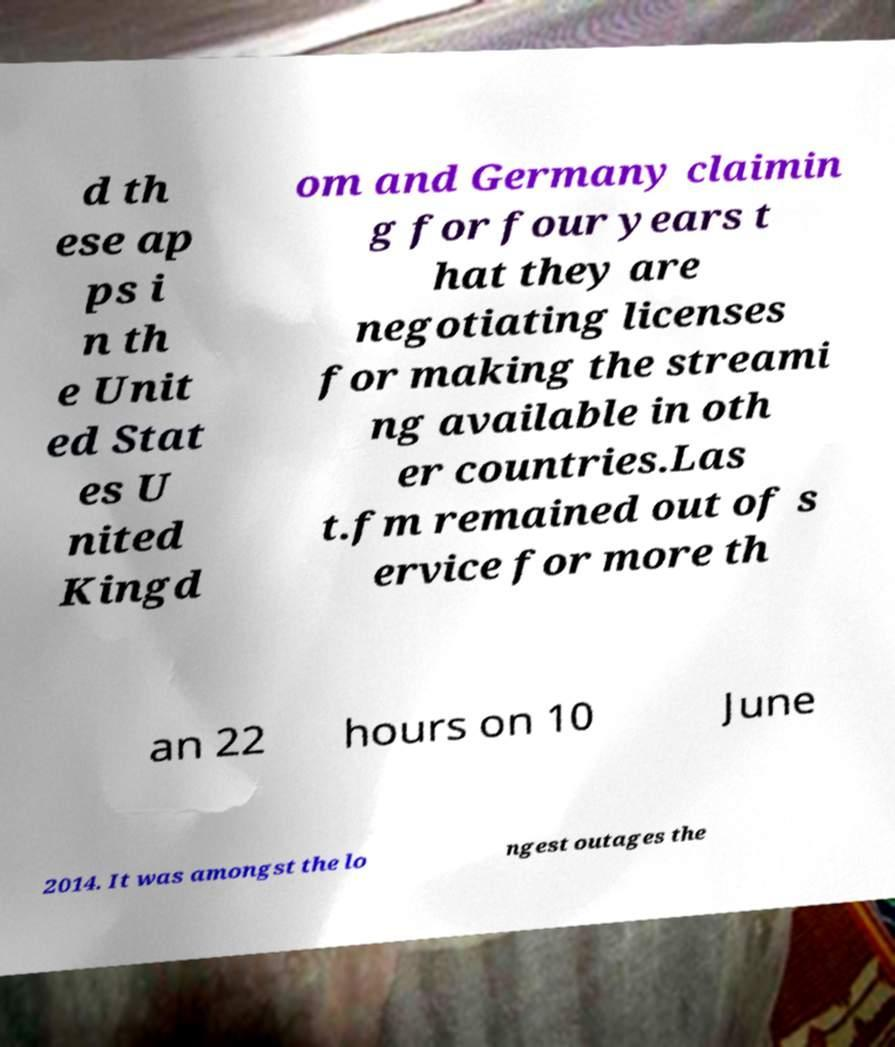Could you assist in decoding the text presented in this image and type it out clearly? d th ese ap ps i n th e Unit ed Stat es U nited Kingd om and Germany claimin g for four years t hat they are negotiating licenses for making the streami ng available in oth er countries.Las t.fm remained out of s ervice for more th an 22 hours on 10 June 2014. It was amongst the lo ngest outages the 